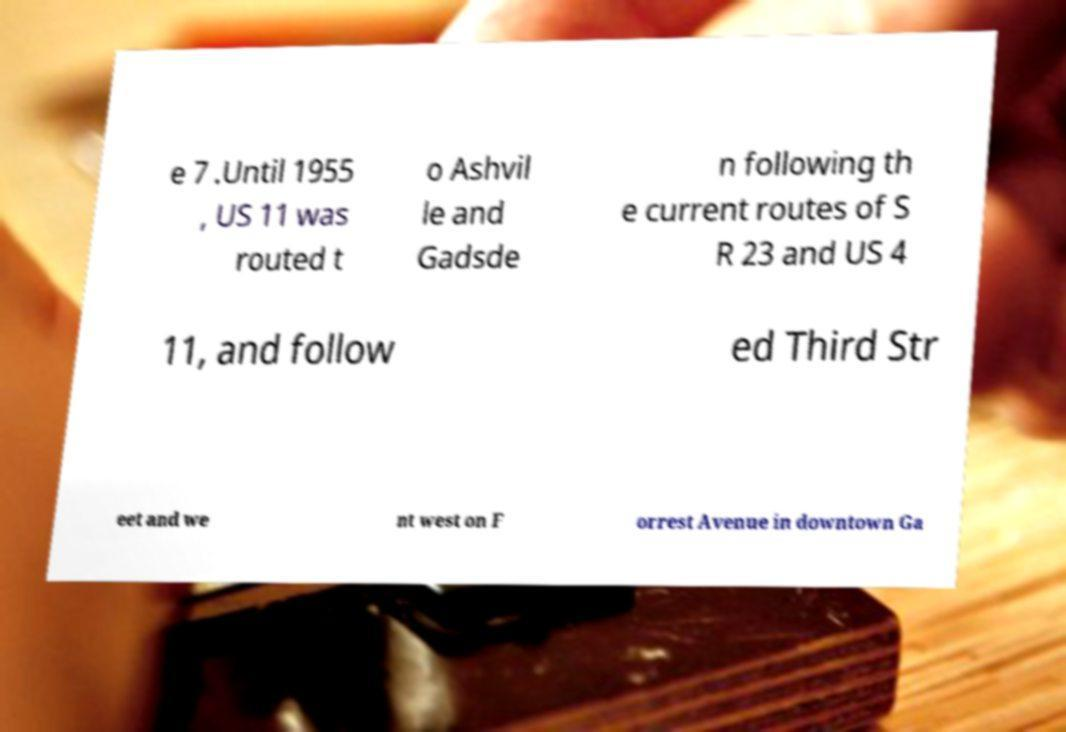Can you read and provide the text displayed in the image?This photo seems to have some interesting text. Can you extract and type it out for me? e 7 .Until 1955 , US 11 was routed t o Ashvil le and Gadsde n following th e current routes of S R 23 and US 4 11, and follow ed Third Str eet and we nt west on F orrest Avenue in downtown Ga 